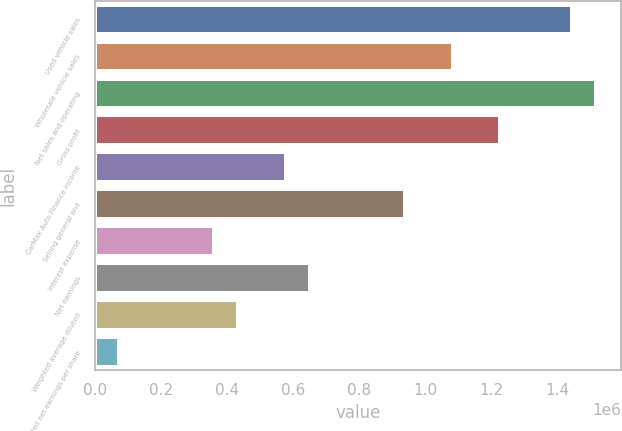Convert chart. <chart><loc_0><loc_0><loc_500><loc_500><bar_chart><fcel>Used vehicle sales<fcel>Wholesale vehicle sales<fcel>Net sales and operating<fcel>Gross profit<fcel>CarMax Auto Finance income<fcel>Selling general and<fcel>Interest expense<fcel>Net earnings<fcel>Weighted average diluted<fcel>Diluted net earnings per share<nl><fcel>1.44302e+06<fcel>1.08227e+06<fcel>1.51517e+06<fcel>1.22657e+06<fcel>577210<fcel>937965<fcel>360757<fcel>649361<fcel>432908<fcel>72153<nl></chart> 